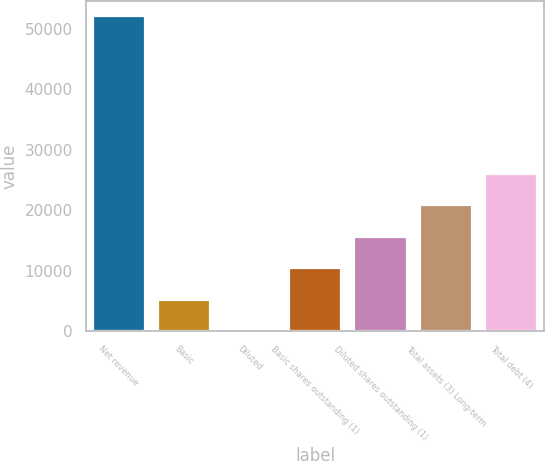Convert chart to OTSL. <chart><loc_0><loc_0><loc_500><loc_500><bar_chart><fcel>Net revenue<fcel>Basic<fcel>Diluted<fcel>Basic shares outstanding (1)<fcel>Diluted shares outstanding (1)<fcel>Total assets (3) Long-term<fcel>Total debt (4)<nl><fcel>52107<fcel>5211.91<fcel>1.34<fcel>10422.5<fcel>15633<fcel>20843.6<fcel>26054.2<nl></chart> 